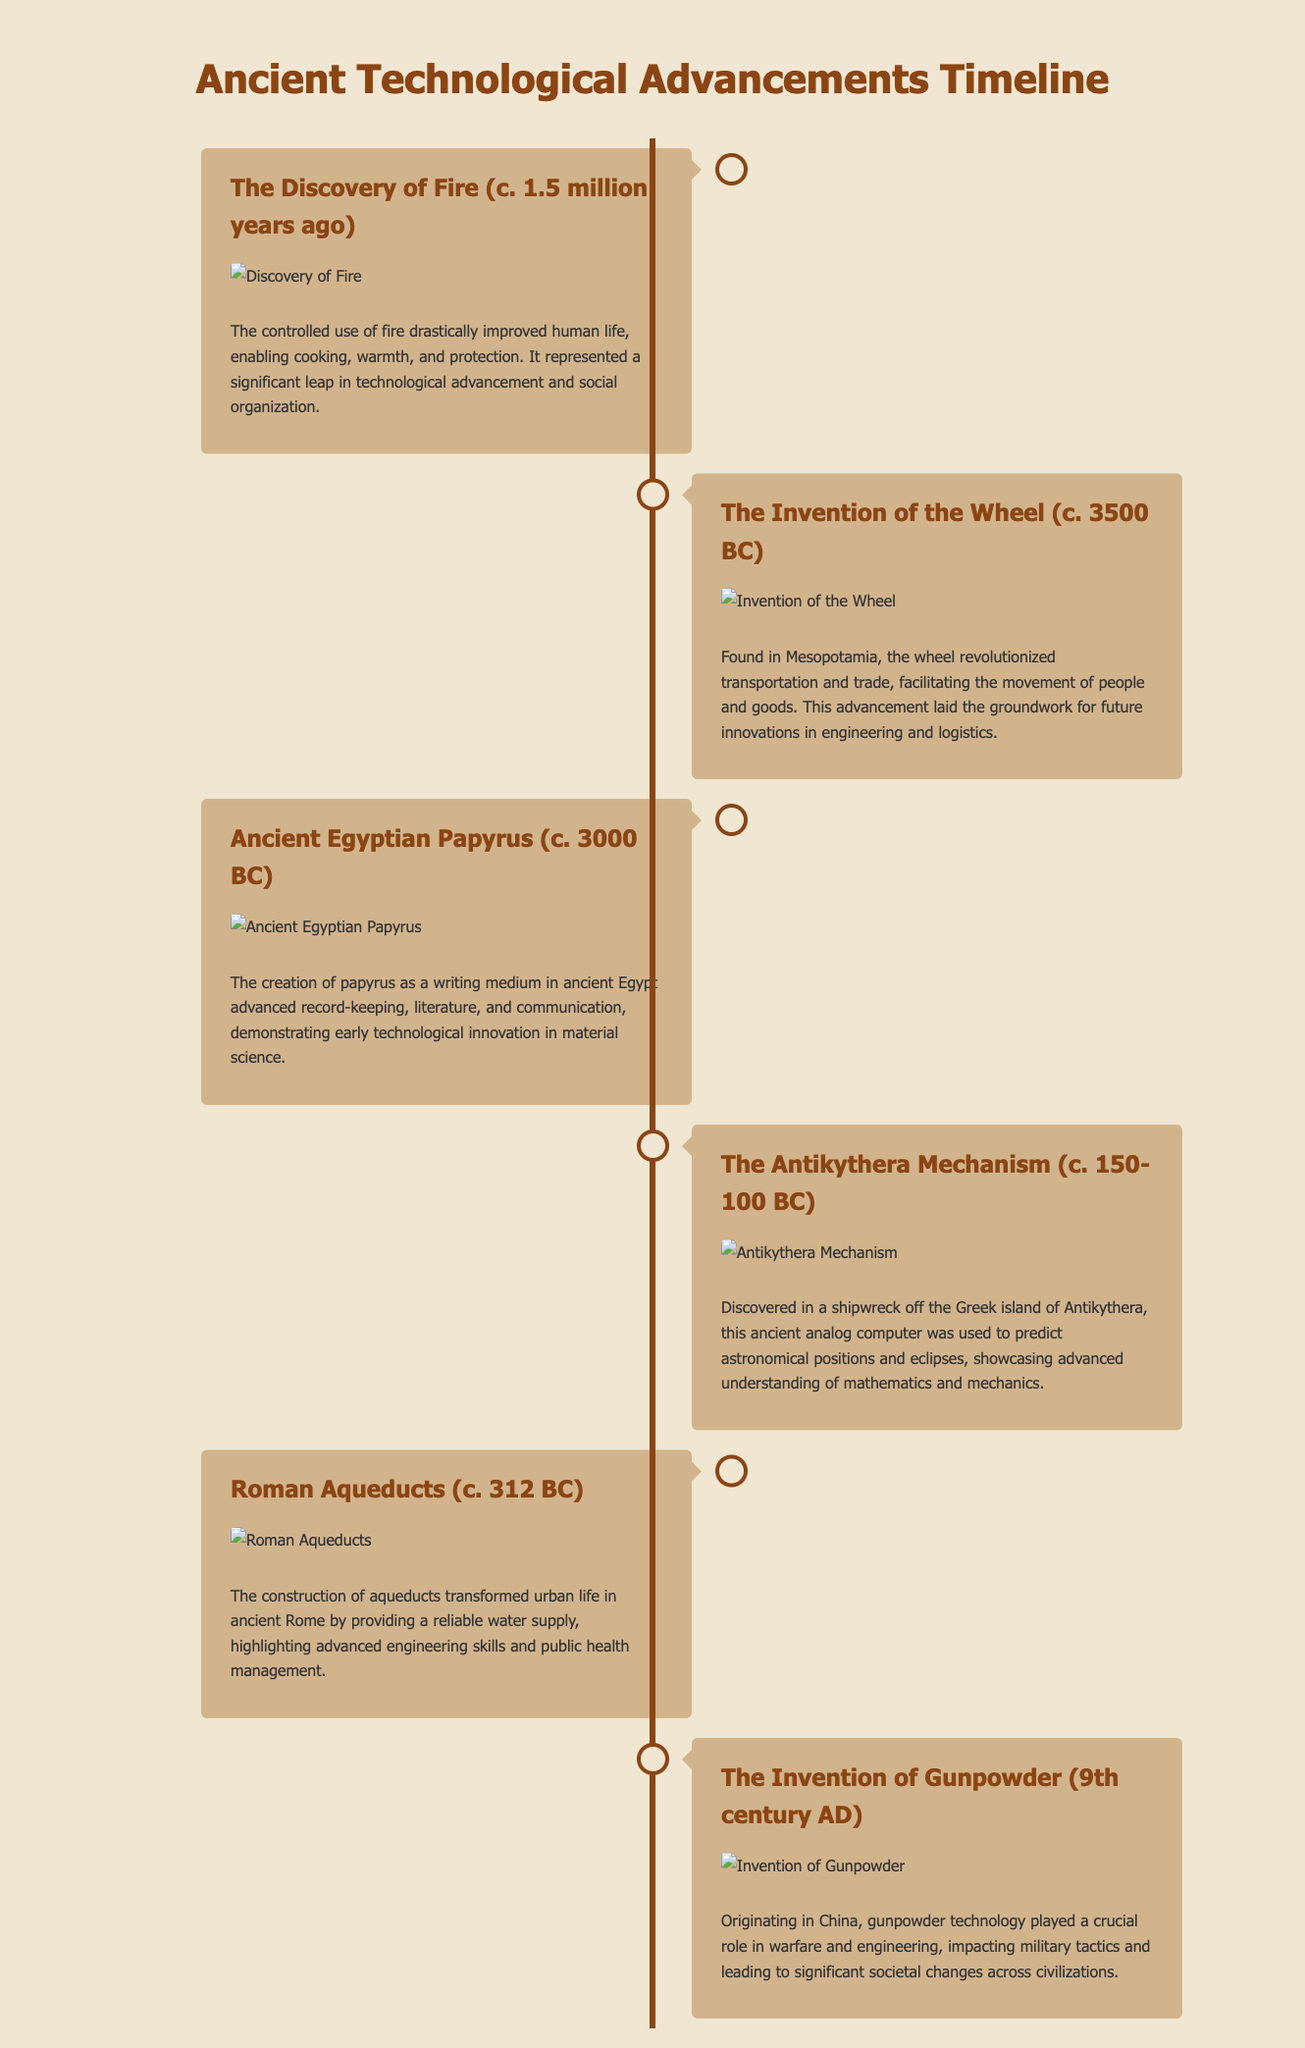What major advancement does the Antikythera Mechanism represent? The Antikythera Mechanism is noted for showcasing advanced understanding of mathematics and mechanics.
Answer: Mathematics and mechanics When was the invention of the wheel? The document states that the wheel was invented around 3500 BC.
Answer: c. 3500 BC Which ancient civilization is credited with the creation of papyrus? The document attributes the creation of papyrus to ancient Egypt.
Answer: Ancient Egypt What was the impact of Roman aqueducts on urban life? Roman aqueducts transformed urban life by providing a reliable water supply.
Answer: Reliable water supply What technology did the Chinese invent in the 9th century? The document mentions the invention of gunpowder as a significant technology from China during this period.
Answer: Gunpowder How long ago was the discovery of fire? The document indicates that the discovery of fire occurred around 1.5 million years ago.
Answer: c. 1.5 million years ago Why is the wheel considered a revolutionary advancement? The wheel revolutionized transportation and trade, facilitating the movement of people and goods.
Answer: Transportation and trade What writing medium advanced literature and communication in ancient Egypt? The document specifies that the writing medium was papyrus.
Answer: Papyrus 